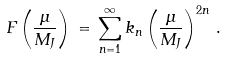Convert formula to latex. <formula><loc_0><loc_0><loc_500><loc_500>F \left ( \frac { \mu } { M _ { J } } \right ) \, = \, \sum _ { n = 1 } ^ { \infty } k _ { n } \left ( \frac { \mu } { M _ { J } } \right ) ^ { 2 n } \, .</formula> 